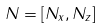Convert formula to latex. <formula><loc_0><loc_0><loc_500><loc_500>N = [ N _ { x } , N _ { z } ]</formula> 